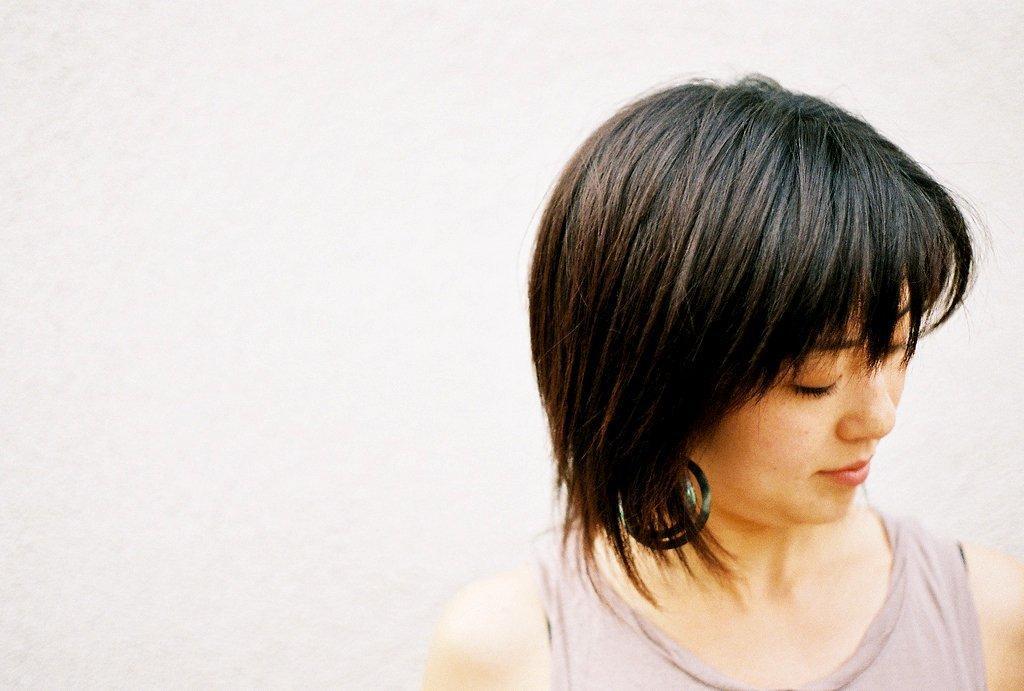In one or two sentences, can you explain what this image depicts? In this image there is a person truncated towards the bottom of the image, at the background of the image there is a wall truncated. 